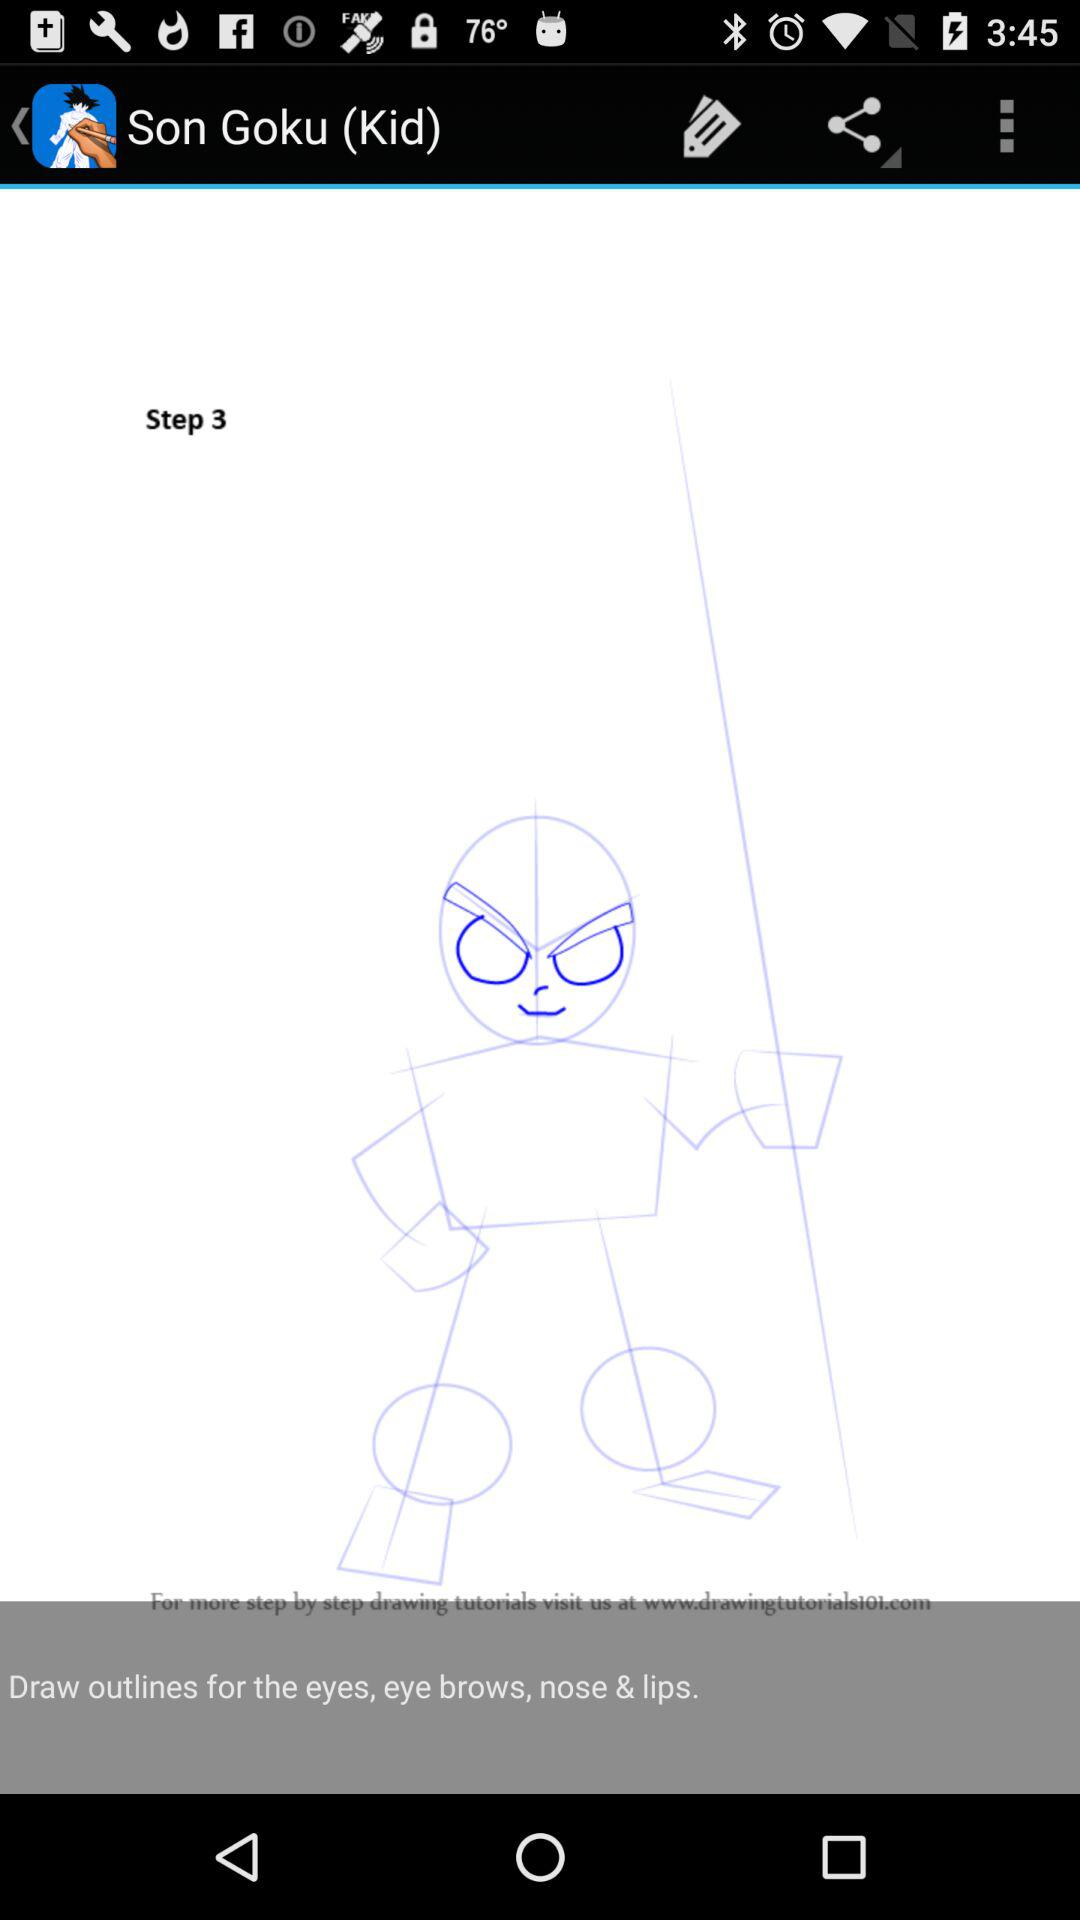What is the current step? The current step is 3. 